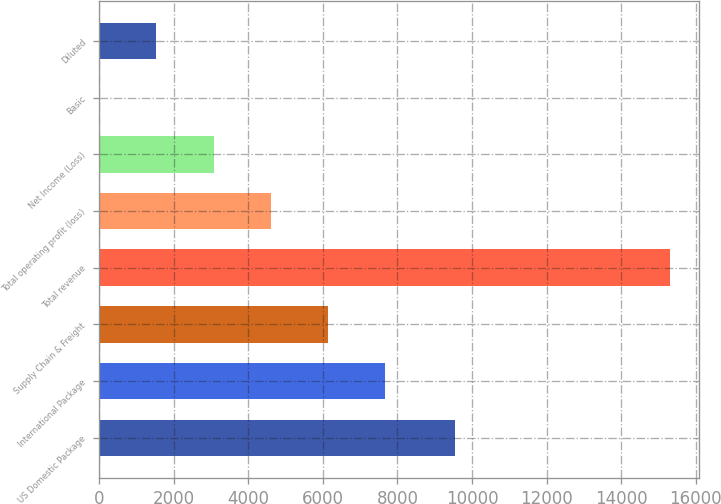Convert chart. <chart><loc_0><loc_0><loc_500><loc_500><bar_chart><fcel>US Domestic Package<fcel>International Package<fcel>Supply Chain & Freight<fcel>Total revenue<fcel>Total operating profit (loss)<fcel>Net Income (Loss)<fcel>Basic<fcel>Diluted<nl><fcel>9535<fcel>7658.17<fcel>6126.8<fcel>15315<fcel>4595.43<fcel>3064.06<fcel>1.32<fcel>1532.69<nl></chart> 